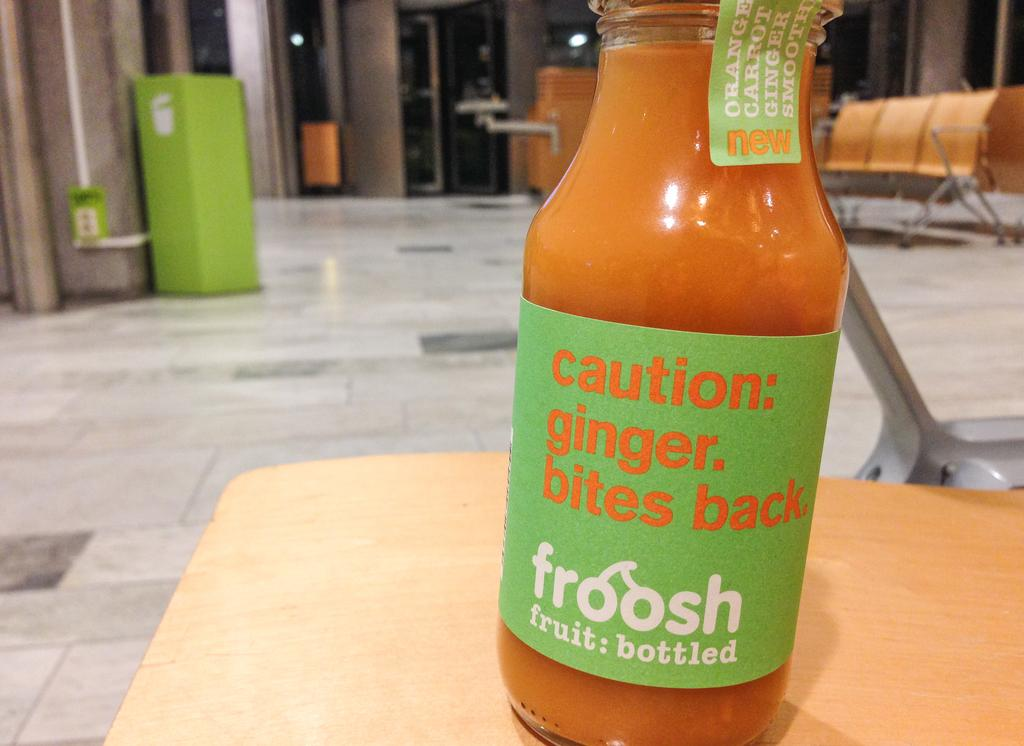<image>
Create a compact narrative representing the image presented. A Froosh bottle of juice has the message caution: ginger bites back. 